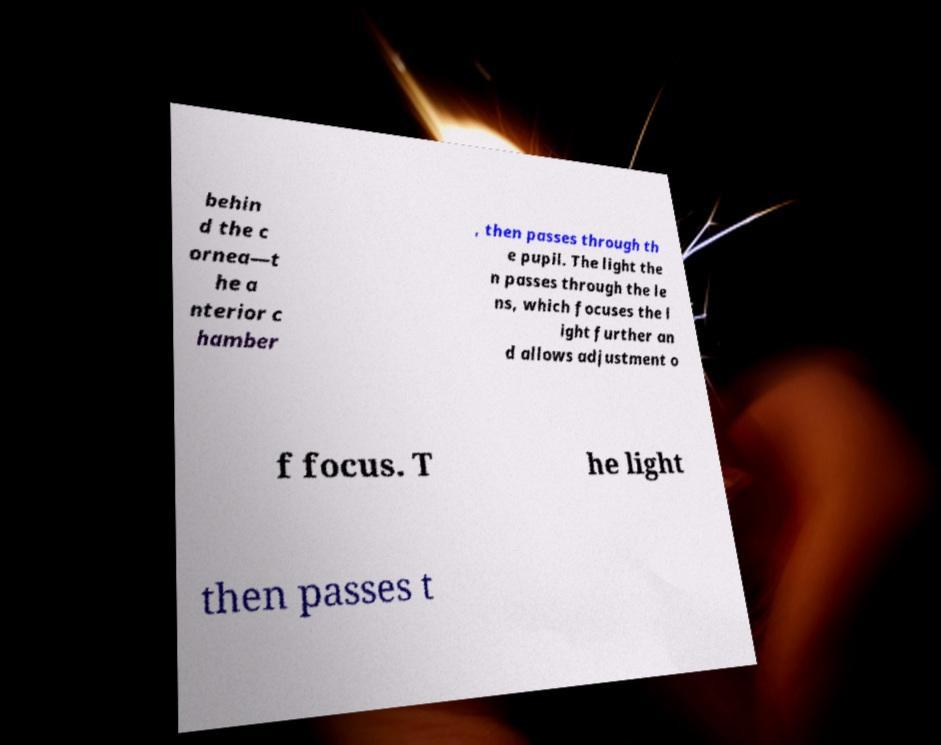There's text embedded in this image that I need extracted. Can you transcribe it verbatim? behin d the c ornea—t he a nterior c hamber , then passes through th e pupil. The light the n passes through the le ns, which focuses the l ight further an d allows adjustment o f focus. T he light then passes t 